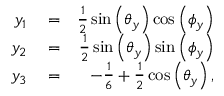<formula> <loc_0><loc_0><loc_500><loc_500>\begin{array} { r l r } { y _ { 1 } } & = } & { \frac { 1 } { 2 } \sin \left ( \theta _ { y } \right ) \cos \left ( \phi _ { y } \right ) } \\ { y _ { 2 } } & = } & { \frac { 1 } { 2 } \sin \left ( \theta _ { y } \right ) \sin \left ( \phi _ { y } \right ) } \\ { y _ { 3 } } & = } & { - \frac { 1 } { 6 } + \frac { 1 } { 2 } \cos \left ( \theta _ { y } \right ) , } \end{array}</formula> 